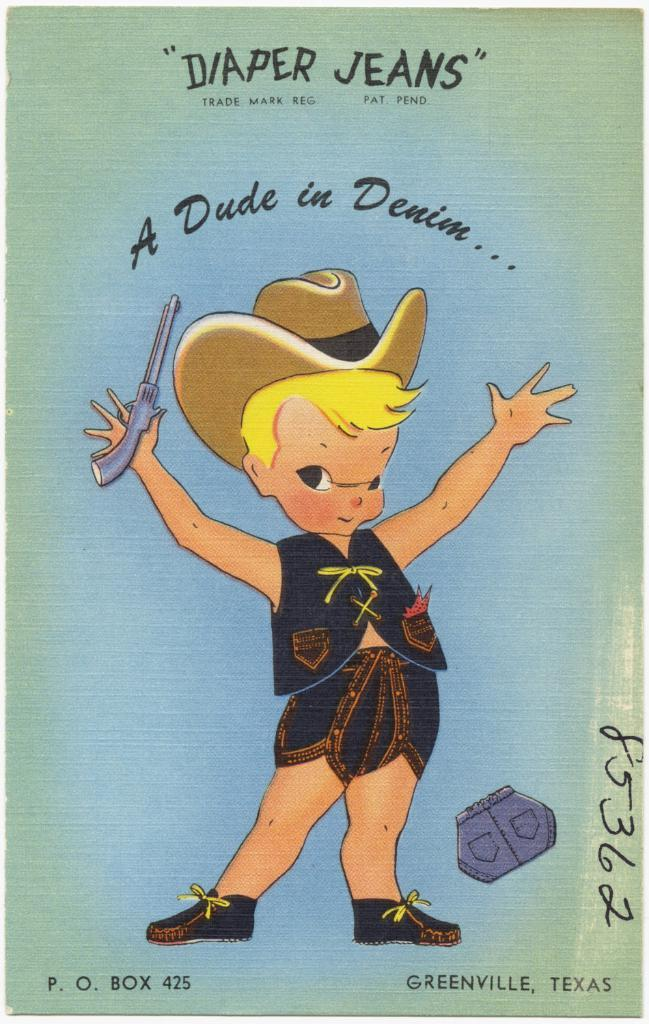What type of poster is in the image? There is a cartoon poster in the image. What is depicted on the cartoon poster? The cartoon poster features a person. Are there any words on the cartoon poster? Yes, there is text on the cartoon poster. What type of instrument is being played by the person on the cartoon poster? There is no instrument visible on the cartoon poster; it only features a person and text. 